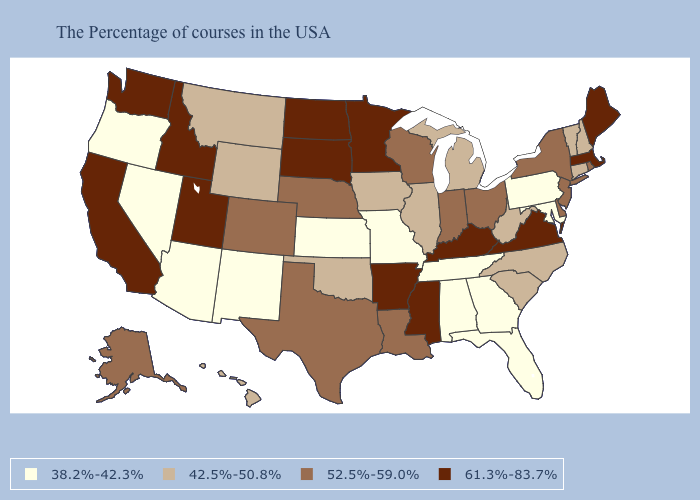Does Colorado have the highest value in the USA?
Be succinct. No. What is the lowest value in the USA?
Short answer required. 38.2%-42.3%. Among the states that border West Virginia , which have the highest value?
Write a very short answer. Virginia, Kentucky. Does the first symbol in the legend represent the smallest category?
Be succinct. Yes. Which states have the lowest value in the USA?
Answer briefly. Maryland, Pennsylvania, Florida, Georgia, Alabama, Tennessee, Missouri, Kansas, New Mexico, Arizona, Nevada, Oregon. Name the states that have a value in the range 52.5%-59.0%?
Answer briefly. Rhode Island, New York, New Jersey, Delaware, Ohio, Indiana, Wisconsin, Louisiana, Nebraska, Texas, Colorado, Alaska. Which states hav the highest value in the Northeast?
Give a very brief answer. Maine, Massachusetts. Does California have the highest value in the West?
Write a very short answer. Yes. Among the states that border Idaho , which have the lowest value?
Give a very brief answer. Nevada, Oregon. Name the states that have a value in the range 52.5%-59.0%?
Give a very brief answer. Rhode Island, New York, New Jersey, Delaware, Ohio, Indiana, Wisconsin, Louisiana, Nebraska, Texas, Colorado, Alaska. Name the states that have a value in the range 42.5%-50.8%?
Answer briefly. New Hampshire, Vermont, Connecticut, North Carolina, South Carolina, West Virginia, Michigan, Illinois, Iowa, Oklahoma, Wyoming, Montana, Hawaii. What is the lowest value in the USA?
Short answer required. 38.2%-42.3%. What is the value of New Mexico?
Give a very brief answer. 38.2%-42.3%. What is the value of North Carolina?
Keep it brief. 42.5%-50.8%. What is the value of Alaska?
Quick response, please. 52.5%-59.0%. 